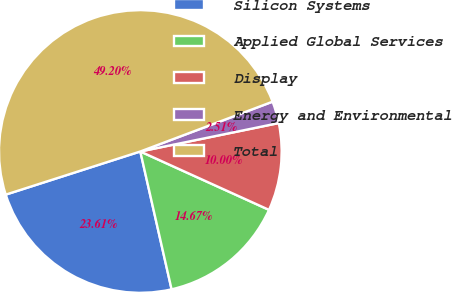Convert chart. <chart><loc_0><loc_0><loc_500><loc_500><pie_chart><fcel>Silicon Systems<fcel>Applied Global Services<fcel>Display<fcel>Energy and Environmental<fcel>Total<nl><fcel>23.61%<fcel>14.67%<fcel>10.0%<fcel>2.51%<fcel>49.2%<nl></chart> 